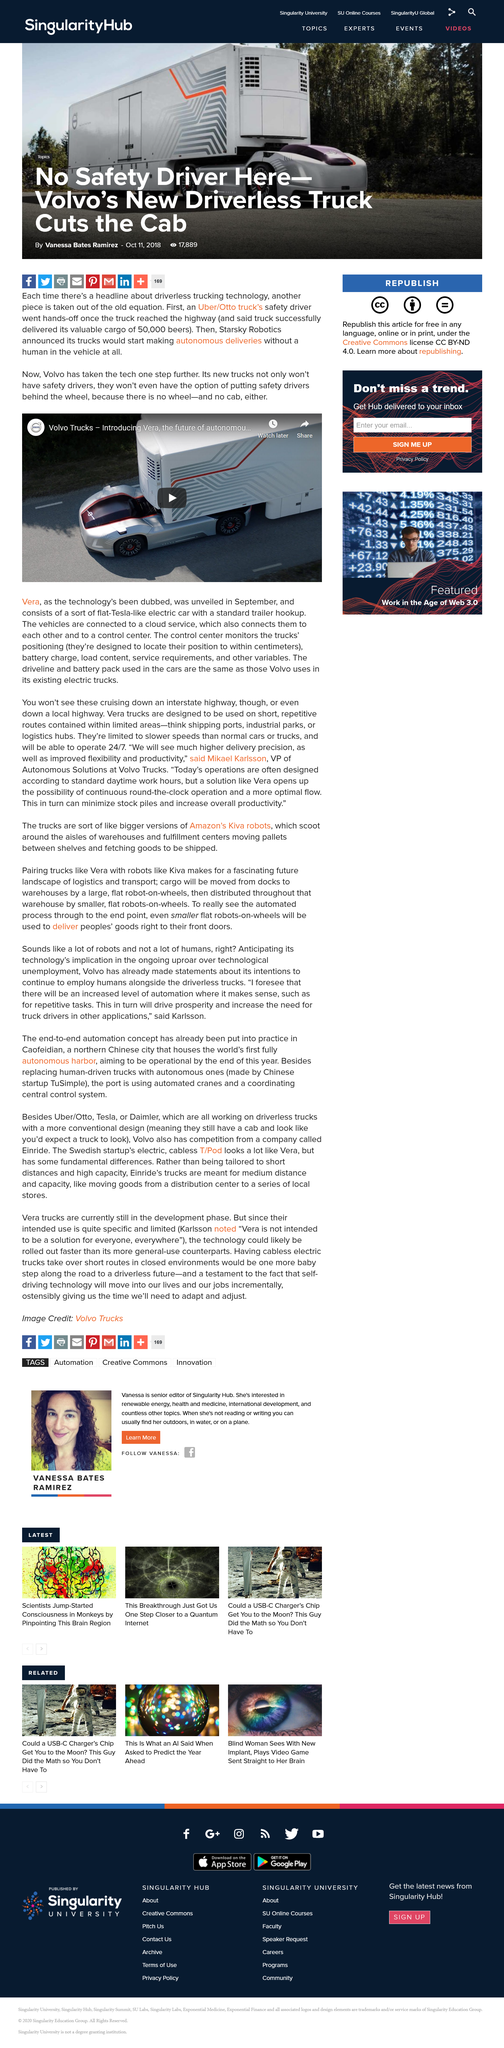Mention a couple of crucial points in this snapshot. These cars are Tesla-like electric flat cars. Vera was unveiled in September. The cars are connected to each other and the control center via a cloud service. 